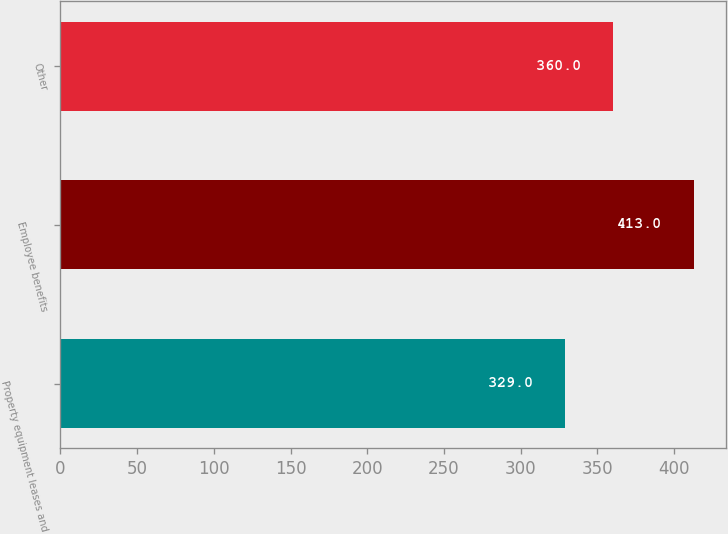<chart> <loc_0><loc_0><loc_500><loc_500><bar_chart><fcel>Property equipment leases and<fcel>Employee benefits<fcel>Other<nl><fcel>329<fcel>413<fcel>360<nl></chart> 